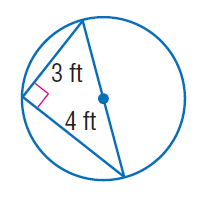Question: Find the exact circumference of the circle.
Choices:
A. 2.5 \pi
B. 15
C. 5 \pi
D. 10 \pi
Answer with the letter. Answer: C 